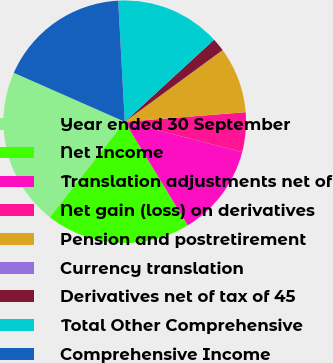<chart> <loc_0><loc_0><loc_500><loc_500><pie_chart><fcel>Year ended 30 September<fcel>Net Income<fcel>Translation adjustments net of<fcel>Net gain (loss) on derivatives<fcel>Pension and postretirement<fcel>Currency translation<fcel>Derivatives net of tax of 45<fcel>Total Other Comprehensive<fcel>Comprehensive Income<nl><fcel>21.03%<fcel>19.28%<fcel>12.28%<fcel>5.28%<fcel>8.78%<fcel>0.02%<fcel>1.77%<fcel>14.03%<fcel>17.53%<nl></chart> 